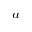<formula> <loc_0><loc_0><loc_500><loc_500>^ { a }</formula> 